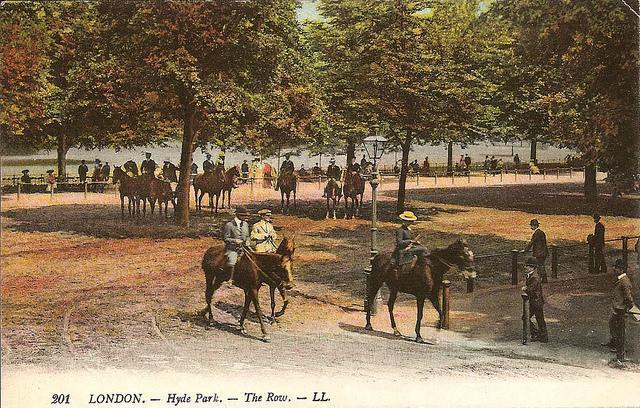How many horses can you see?
Give a very brief answer. 2. 